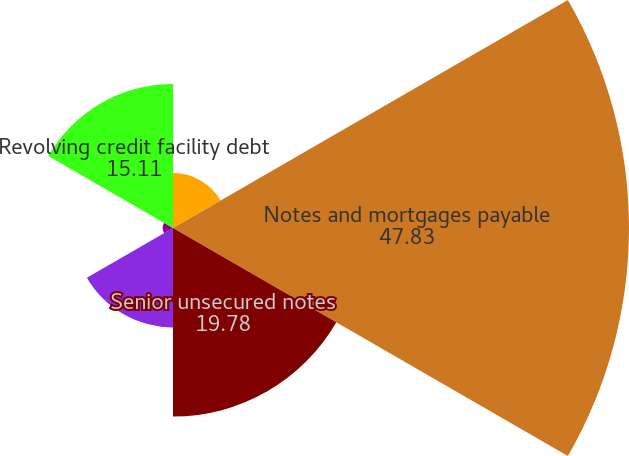Convert chart. <chart><loc_0><loc_0><loc_500><loc_500><pie_chart><fcel>Mezzanine loans receivable<fcel>Notes and mortgages payable<fcel>Senior unsecured notes<fcel>Exchangeable senior debentures<fcel>Convertible senior debentures<fcel>Revolving credit facility debt<nl><fcel>5.76%<fcel>47.83%<fcel>19.78%<fcel>10.43%<fcel>1.08%<fcel>15.11%<nl></chart> 